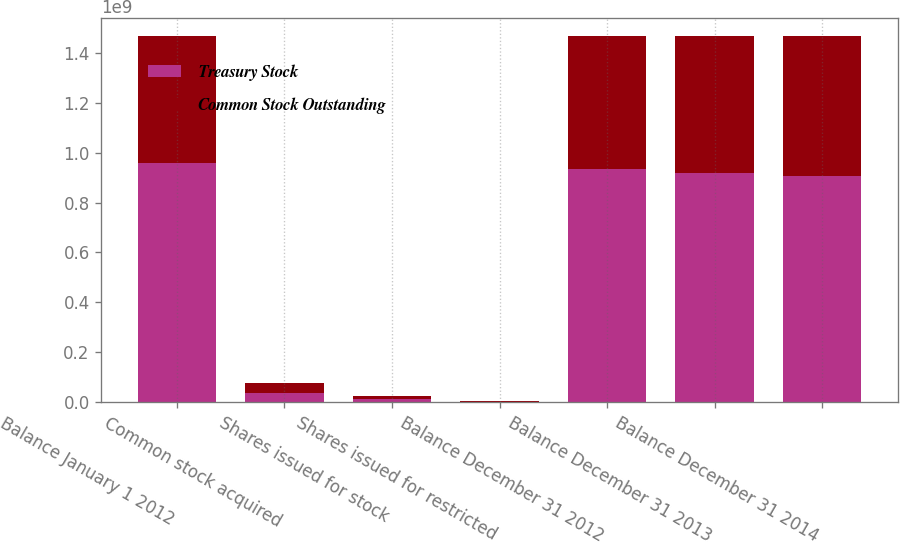<chart> <loc_0><loc_0><loc_500><loc_500><stacked_bar_chart><ecel><fcel>Balance January 1 2012<fcel>Common stock acquired<fcel>Shares issued for stock<fcel>Shares issued for restricted<fcel>Balance December 31 2012<fcel>Balance December 31 2013<fcel>Balance December 31 2014<nl><fcel>Treasury Stock<fcel>9.60036e+08<fcel>3.87306e+07<fcel>1.22172e+07<fcel>2.2059e+06<fcel>9.35729e+08<fcel>9.19947e+08<fcel>9.06712e+08<nl><fcel>Common Stock Outstanding<fcel>5.0567e+08<fcel>3.87306e+07<fcel>1.22172e+07<fcel>2.2059e+06<fcel>5.29978e+08<fcel>5.4576e+08<fcel>5.58994e+08<nl></chart> 